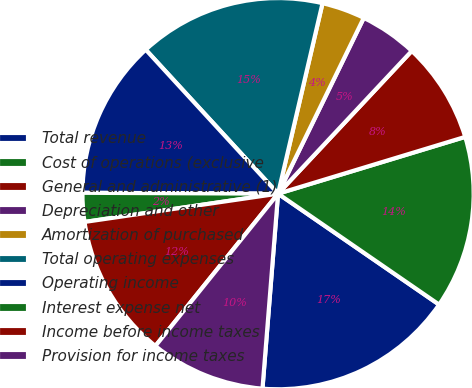Convert chart. <chart><loc_0><loc_0><loc_500><loc_500><pie_chart><fcel>Total revenue<fcel>Cost of operations (exclusive<fcel>General and administrative (1)<fcel>Depreciation and other<fcel>Amortization of purchased<fcel>Total operating expenses<fcel>Operating income<fcel>Interest expense net<fcel>Income before income taxes<fcel>Provision for income taxes<nl><fcel>16.67%<fcel>14.29%<fcel>8.33%<fcel>4.76%<fcel>3.57%<fcel>15.48%<fcel>13.1%<fcel>2.38%<fcel>11.9%<fcel>9.52%<nl></chart> 